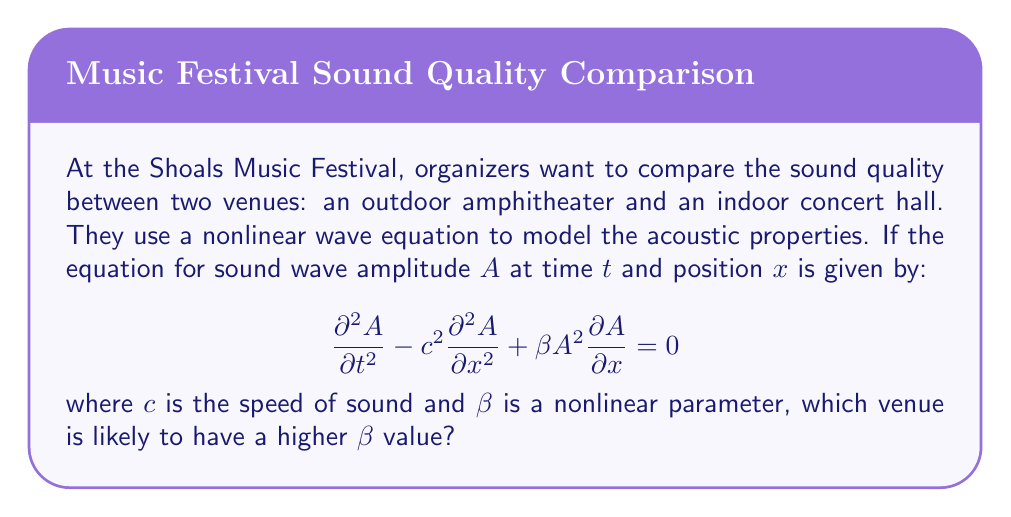Can you answer this question? To answer this question, we need to understand the implications of the nonlinear wave equation and how it relates to different music venues:

1. The equation given is a nonlinear wave equation that describes the propagation of sound waves in a medium. The term $\beta A^2 \frac{\partial A}{\partial x}$ represents the nonlinear effects.

2. The parameter $\beta$ quantifies the strength of the nonlinear effects. A higher $\beta$ value indicates stronger nonlinear distortion of the sound waves.

3. In an indoor concert hall:
   - Sound waves reflect off walls, floors, and ceilings.
   - The enclosed space leads to more interactions between sound waves.
   - These interactions increase the likelihood of wave superposition and nonlinear effects.

4. In an outdoor amphitheater:
   - Sound waves can disperse more freely into the open air.
   - There are fewer surfaces for reflection and less wave interaction.
   - The open environment reduces the buildup of nonlinear effects.

5. Therefore, the indoor concert hall is likely to experience stronger nonlinear effects due to the confined space and multiple reflections.

6. This stronger nonlinearity in the indoor venue would be represented by a higher $\beta$ value in the wave equation.
Answer: Indoor concert hall 